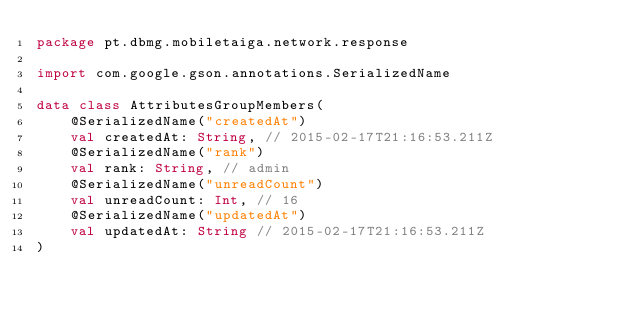Convert code to text. <code><loc_0><loc_0><loc_500><loc_500><_Kotlin_>package pt.dbmg.mobiletaiga.network.response

import com.google.gson.annotations.SerializedName

data class AttributesGroupMembers(
    @SerializedName("createdAt")
    val createdAt: String, // 2015-02-17T21:16:53.211Z
    @SerializedName("rank")
    val rank: String, // admin
    @SerializedName("unreadCount")
    val unreadCount: Int, // 16
    @SerializedName("updatedAt")
    val updatedAt: String // 2015-02-17T21:16:53.211Z
)</code> 